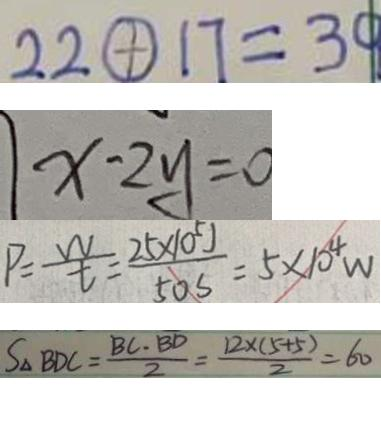Convert formula to latex. <formula><loc_0><loc_0><loc_500><loc_500>2 2 \textcircled { + } 1 7 = 3 0 
 x - 2 y = 0 
 P = \frac { w } { t } = \frac { 2 5 \times 1 0 ^ { 5 } J } { 5 0 s } = 5 \times 1 0 ^ { 4 } w 
 S _ { \Delta B D C } = \frac { B C \cdot B D } { 2 } = \frac { 1 2 \times ( 5 + 5 ) } { 2 } = 6 0</formula> 